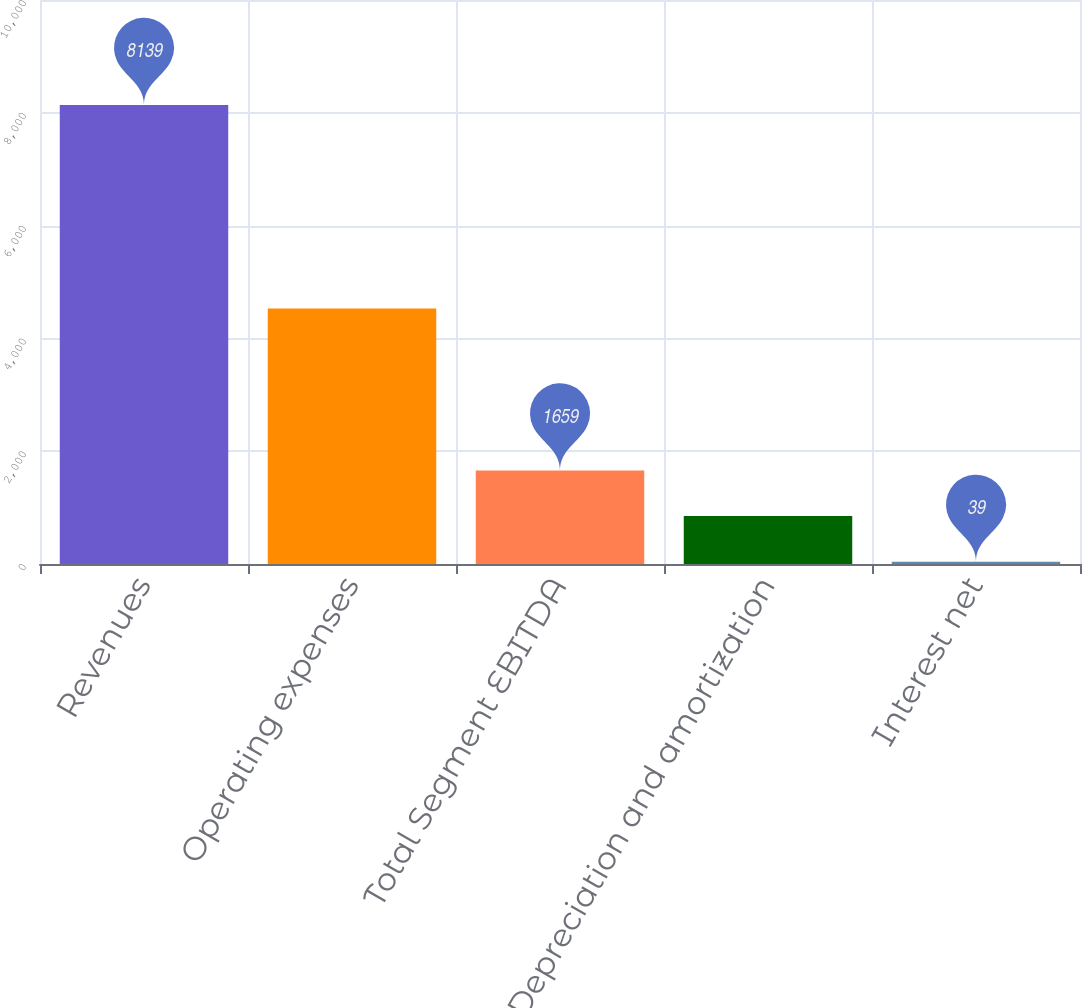Convert chart. <chart><loc_0><loc_0><loc_500><loc_500><bar_chart><fcel>Revenues<fcel>Operating expenses<fcel>Total Segment EBITDA<fcel>Depreciation and amortization<fcel>Interest net<nl><fcel>8139<fcel>4529<fcel>1659<fcel>849<fcel>39<nl></chart> 